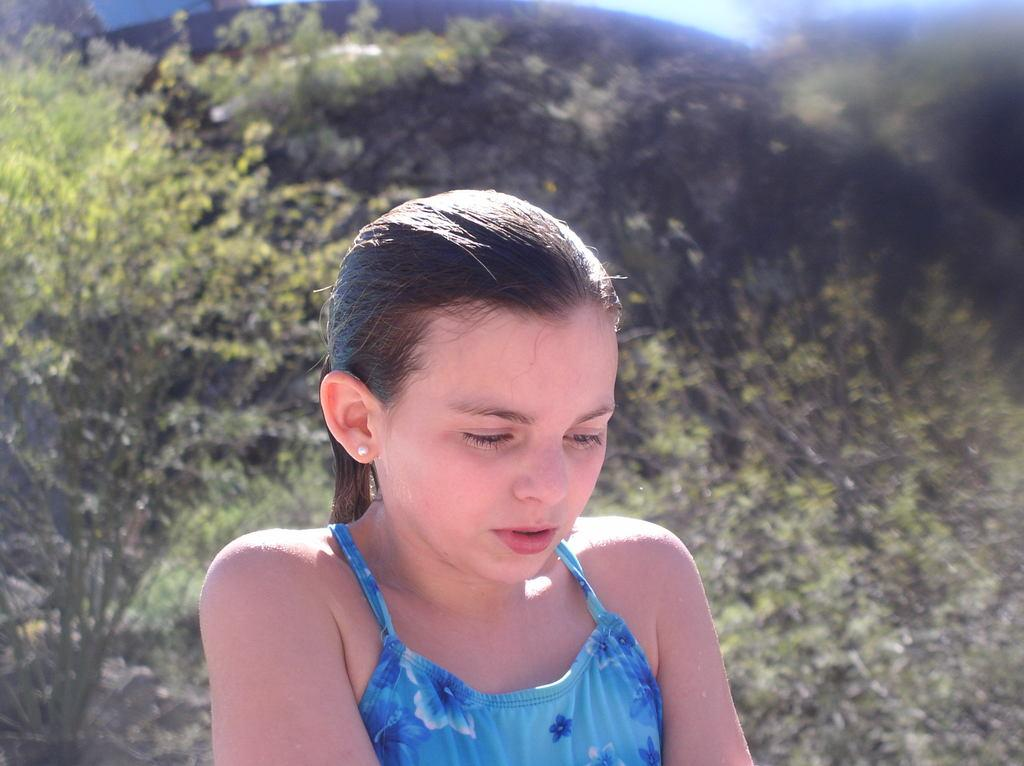What is the main subject of the image? The main subject of the image is a girl. What is the girl wearing in the image? The girl is wearing a blue dress. What can be seen in the background of the image? There are plants in the background of the image. What type of passenger can be seen in the image? There is no passenger present in the image; it features a girl wearing a blue dress. What sound can be heard coming from the girl in the image? There is no sound present in the image, as it is a still photograph. 